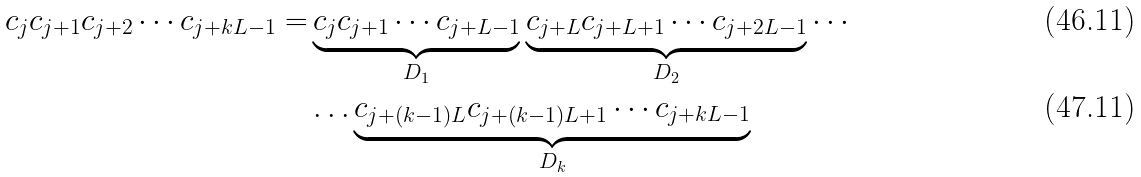Convert formula to latex. <formula><loc_0><loc_0><loc_500><loc_500>c _ { j } c _ { j + 1 } c _ { j + 2 } \cdots c _ { j + k L - 1 } = & \underbrace { c _ { j } c _ { j + 1 } \cdots c _ { j + L - 1 } } _ { D _ { 1 } } \underbrace { c _ { j + L } c _ { j + L + 1 } \cdots c _ { j + 2 L - 1 } } _ { D _ { 2 } } \cdots \\ & \dots \underbrace { c _ { j + ( k - 1 ) L } c _ { j + ( k - 1 ) L + 1 } \cdots c _ { j + k L - 1 } } _ { D _ { k } }</formula> 